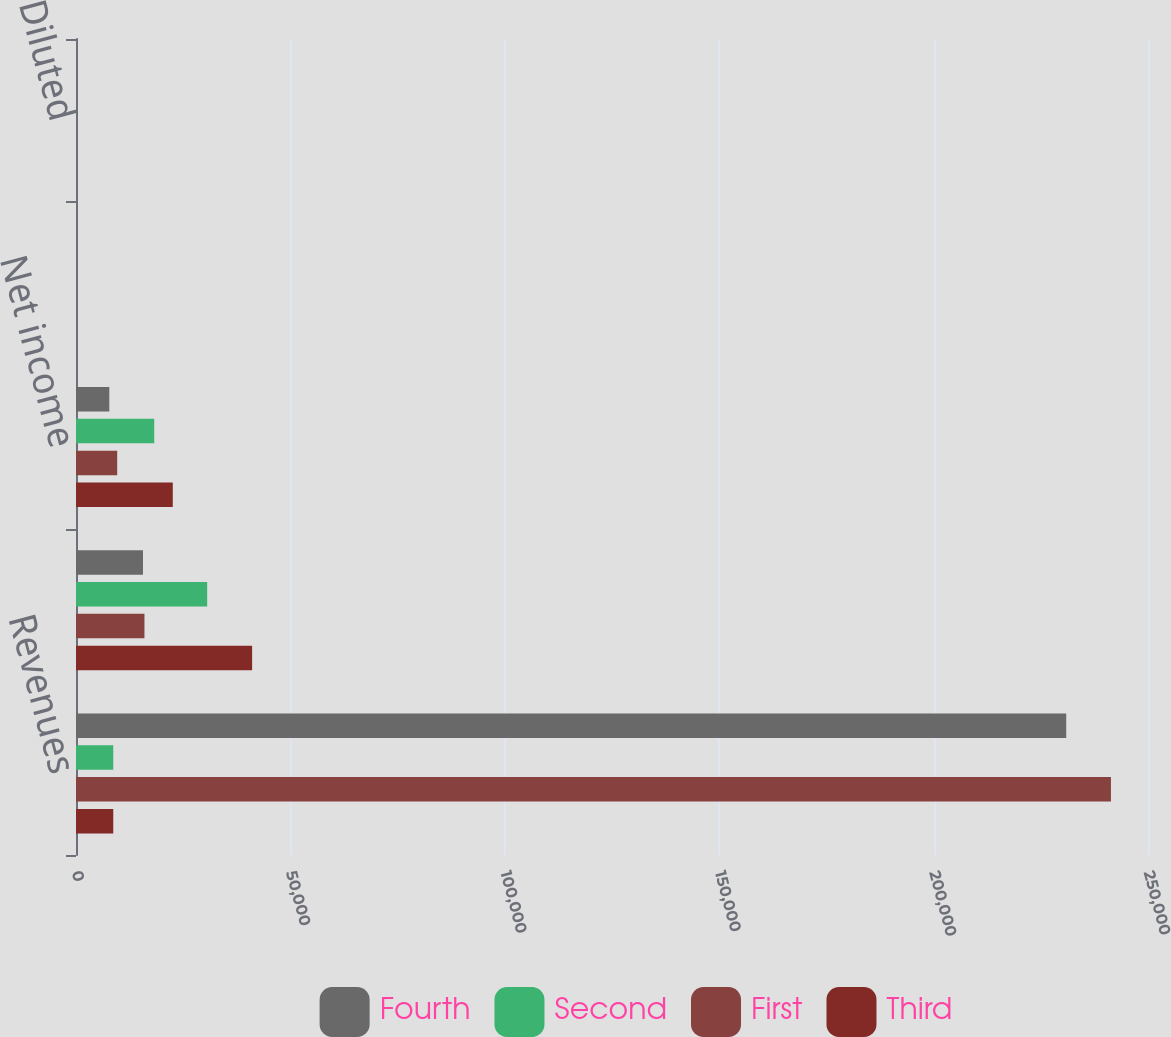<chart> <loc_0><loc_0><loc_500><loc_500><stacked_bar_chart><ecel><fcel>Revenues<fcel>Operating income (1)<fcel>Net income<fcel>Basic<fcel>Diluted<nl><fcel>Fourth<fcel>230929<fcel>15620<fcel>7770<fcel>0.07<fcel>0.07<nl><fcel>Second<fcel>8689<fcel>30595<fcel>18244<fcel>0.16<fcel>0.16<nl><fcel>First<fcel>241360<fcel>15963<fcel>9608<fcel>0.08<fcel>0.08<nl><fcel>Third<fcel>8689<fcel>41072<fcel>22570<fcel>0.2<fcel>0.2<nl></chart> 